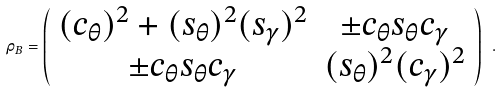Convert formula to latex. <formula><loc_0><loc_0><loc_500><loc_500>\rho _ { B } = \left ( \begin{array} { c c } ( c _ { \theta } ) ^ { 2 } + ( s _ { \theta } ) ^ { 2 } ( s _ { \gamma } ) ^ { 2 } & \pm c _ { \theta } s _ { \theta } c _ { \gamma } \\ \pm c _ { \theta } s _ { \theta } c _ { \gamma } & ( s _ { \theta } ) ^ { 2 } ( c _ { \gamma } ) ^ { 2 } \end{array} \right ) \ .</formula> 